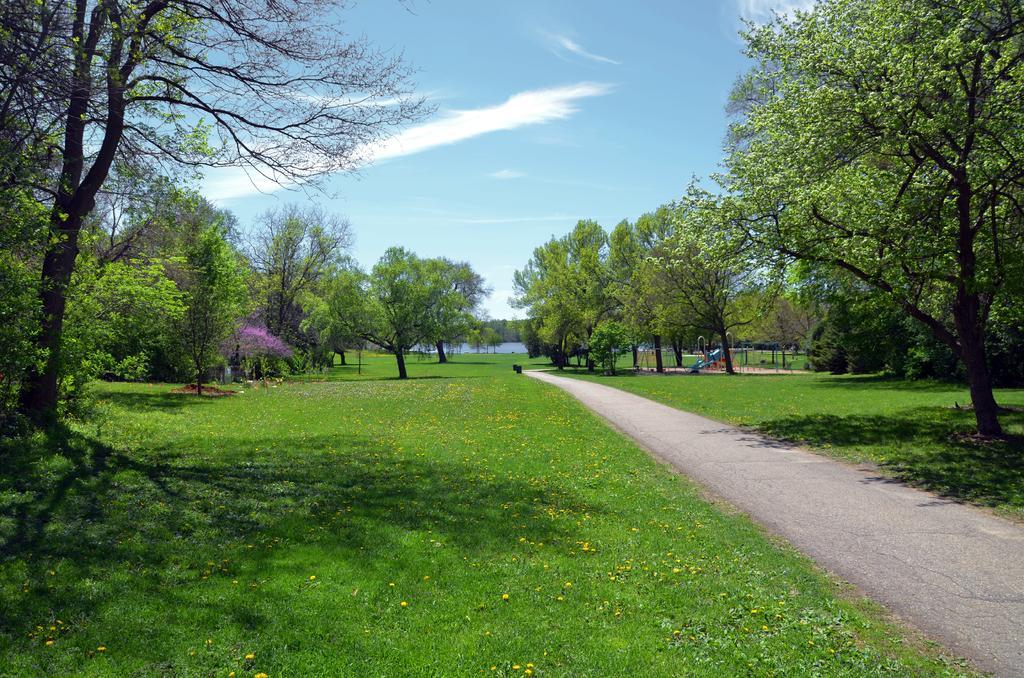Please provide a concise description of this image. In this image we can see trees, plants, grass, and a play area, also we can see water, and the sky, 